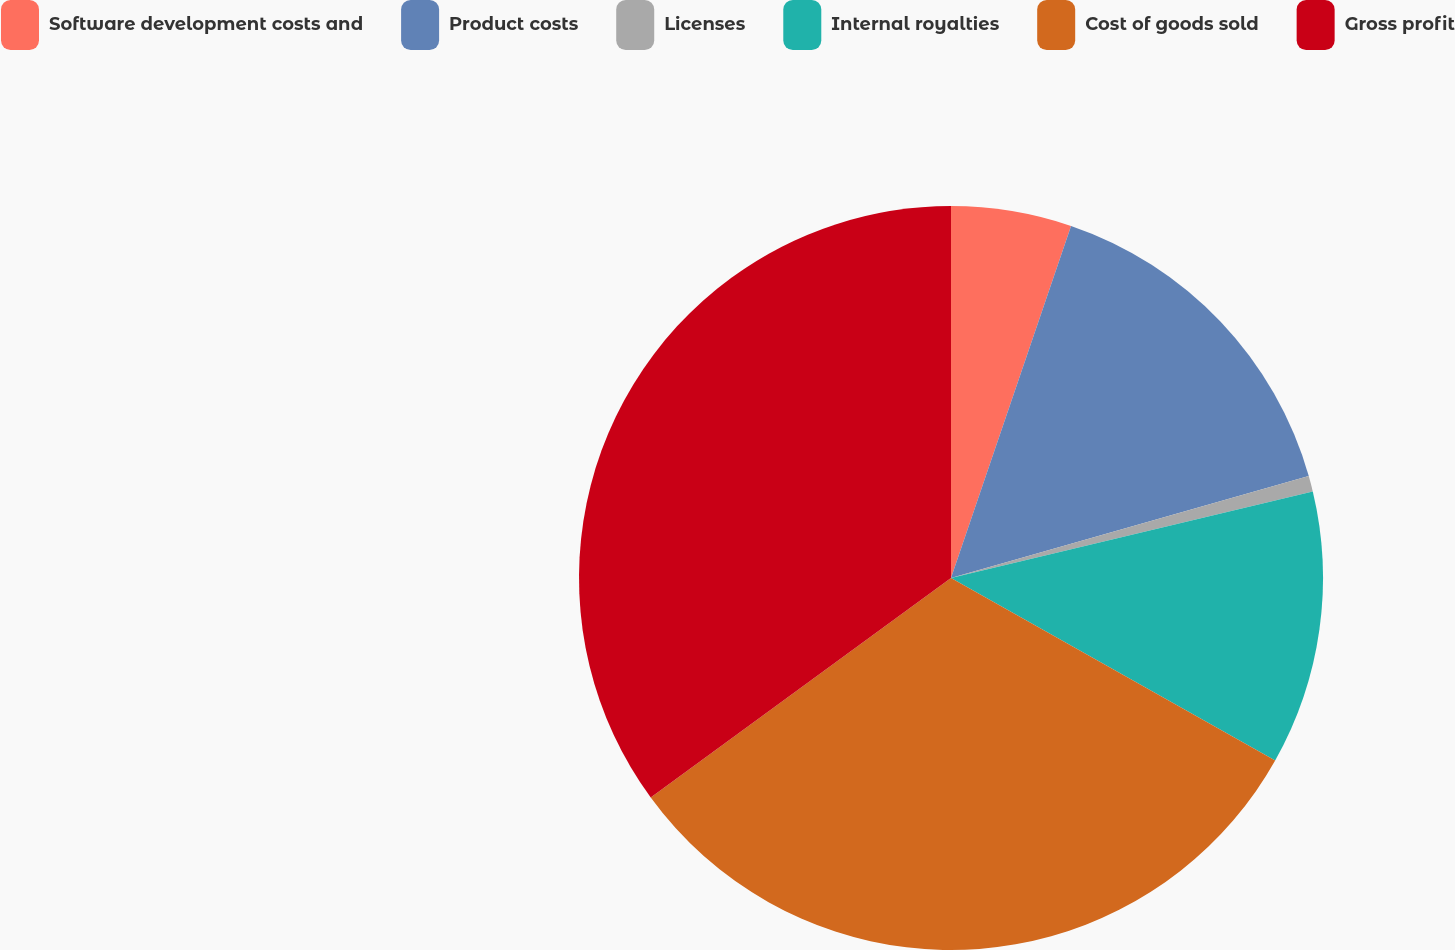Convert chart to OTSL. <chart><loc_0><loc_0><loc_500><loc_500><pie_chart><fcel>Software development costs and<fcel>Product costs<fcel>Licenses<fcel>Internal royalties<fcel>Cost of goods sold<fcel>Gross profit<nl><fcel>5.23%<fcel>15.35%<fcel>0.68%<fcel>11.9%<fcel>31.79%<fcel>35.05%<nl></chart> 